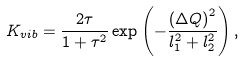<formula> <loc_0><loc_0><loc_500><loc_500>K _ { v i b } = \frac { 2 \tau } { 1 + \tau ^ { 2 } } \exp \left ( - \frac { \left ( \Delta Q \right ) ^ { 2 } } { l _ { 1 } ^ { 2 } + l _ { 2 } ^ { 2 } } \right ) ,</formula> 